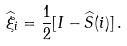<formula> <loc_0><loc_0><loc_500><loc_500>\widehat { \xi } _ { i } = \frac { 1 } { 2 } [ I - \widehat { S } ( i ) ] \, .</formula> 